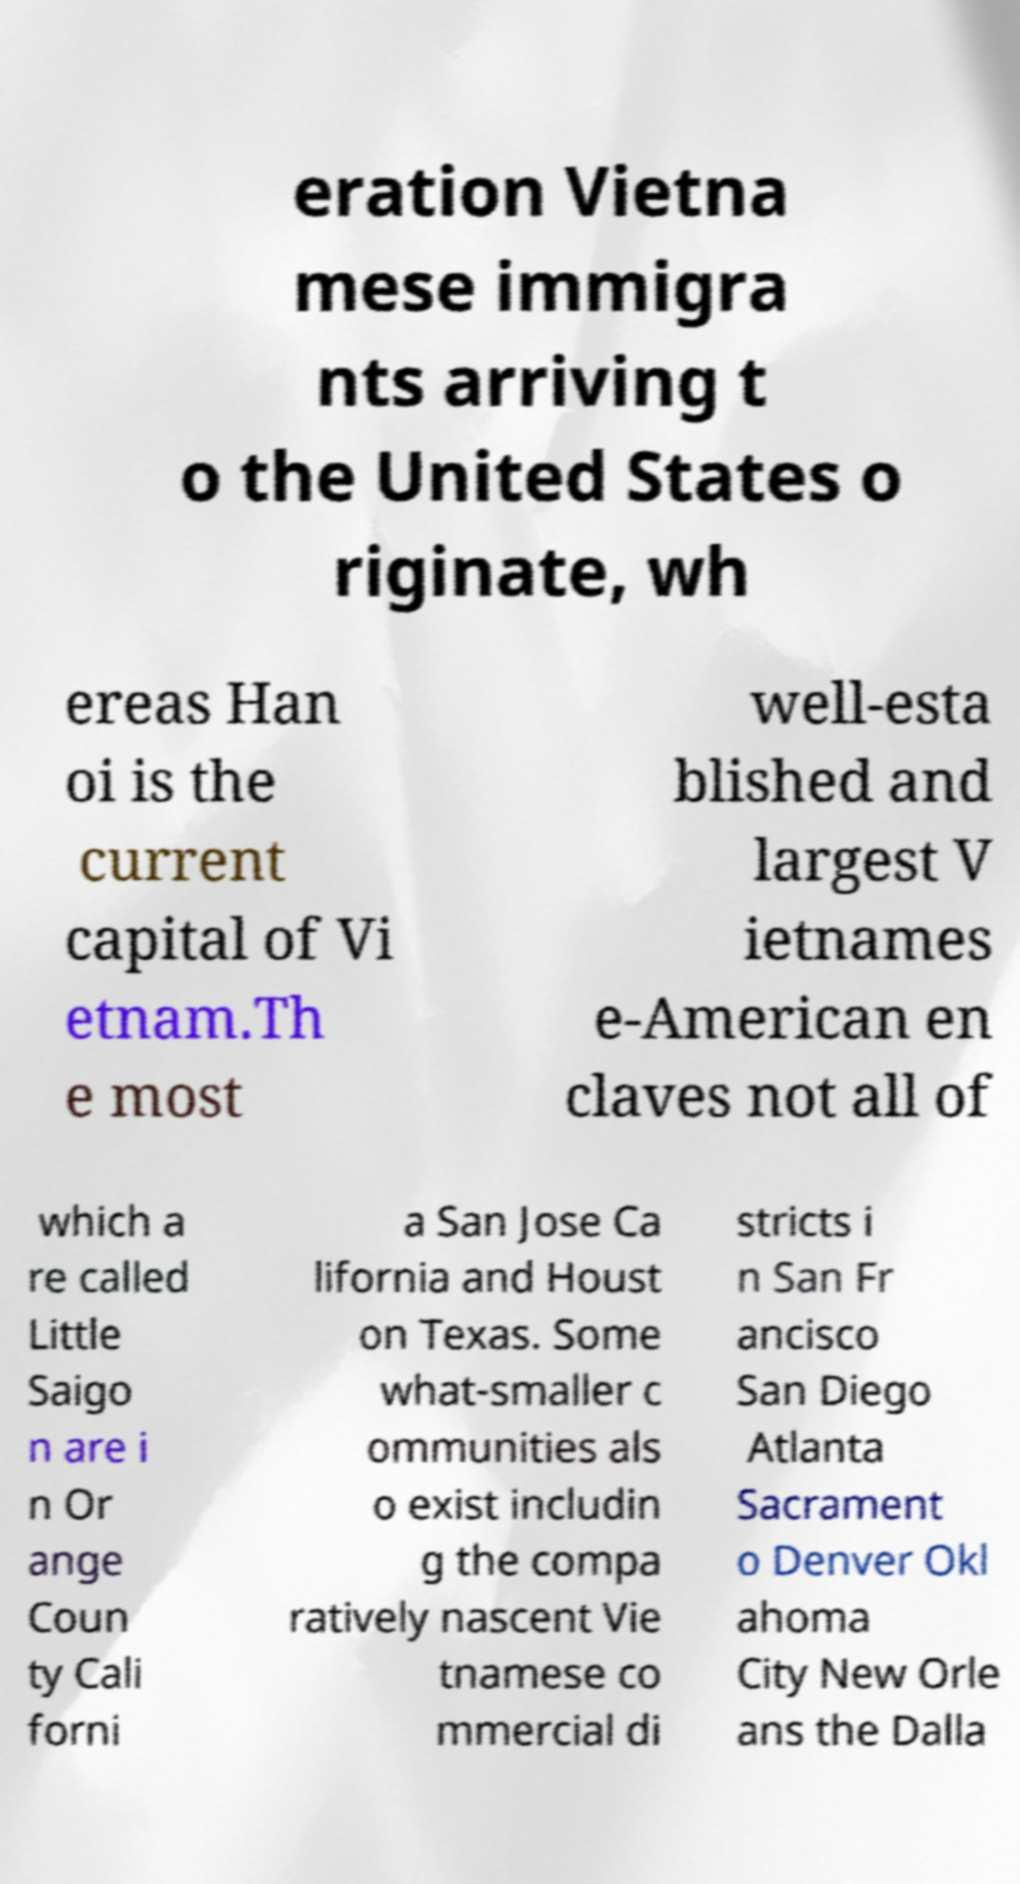For documentation purposes, I need the text within this image transcribed. Could you provide that? eration Vietna mese immigra nts arriving t o the United States o riginate, wh ereas Han oi is the current capital of Vi etnam.Th e most well-esta blished and largest V ietnames e-American en claves not all of which a re called Little Saigo n are i n Or ange Coun ty Cali forni a San Jose Ca lifornia and Houst on Texas. Some what-smaller c ommunities als o exist includin g the compa ratively nascent Vie tnamese co mmercial di stricts i n San Fr ancisco San Diego Atlanta Sacrament o Denver Okl ahoma City New Orle ans the Dalla 